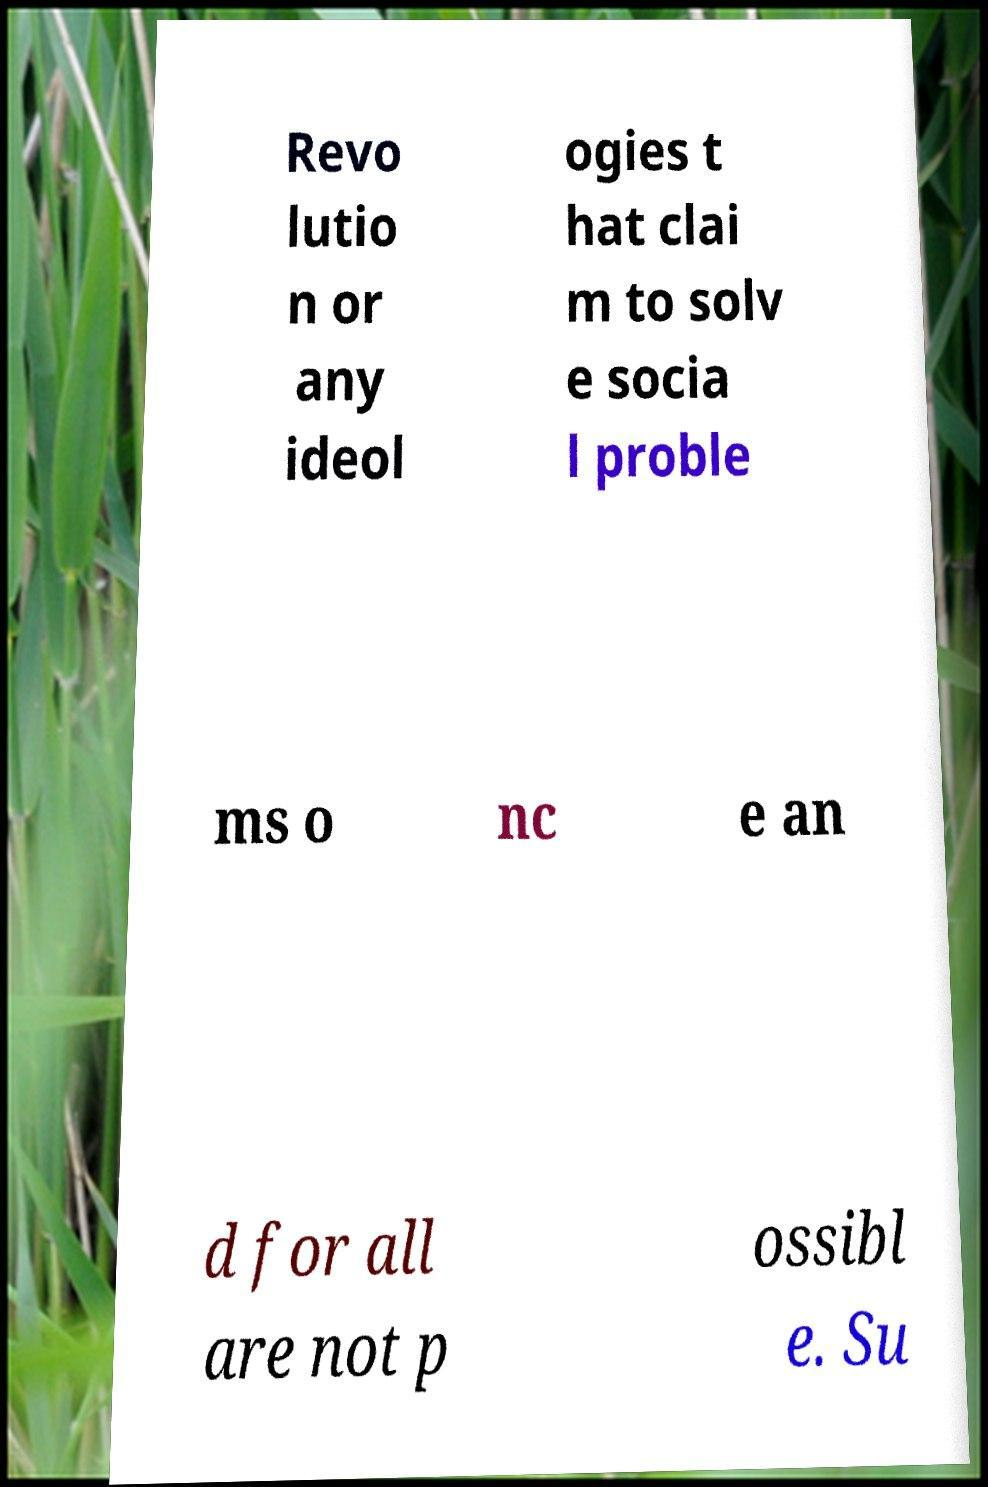Can you accurately transcribe the text from the provided image for me? Revo lutio n or any ideol ogies t hat clai m to solv e socia l proble ms o nc e an d for all are not p ossibl e. Su 